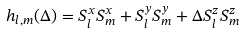<formula> <loc_0><loc_0><loc_500><loc_500>h _ { l , m } ( \Delta ) = S _ { l } ^ { x } S _ { m } ^ { x } + S _ { l } ^ { y } S _ { m } ^ { y } + \Delta S _ { l } ^ { z } S _ { m } ^ { z }</formula> 